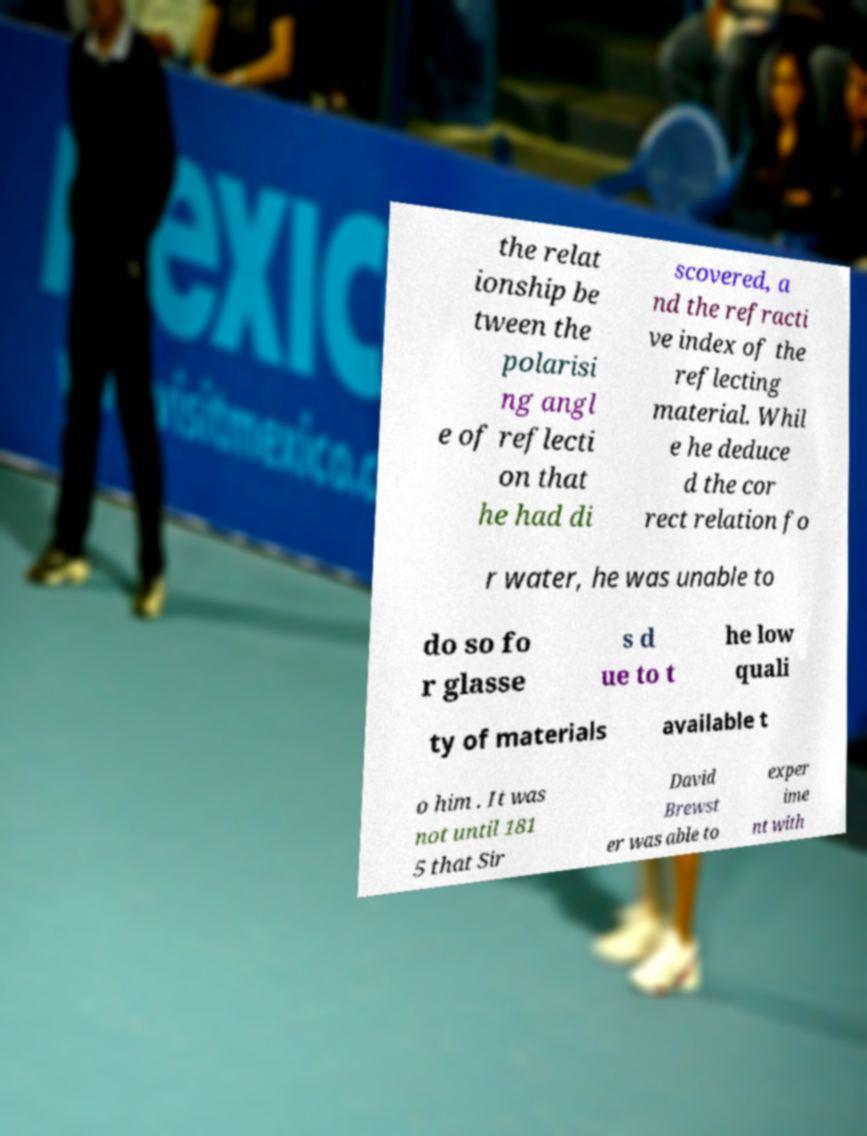Please read and relay the text visible in this image. What does it say? the relat ionship be tween the polarisi ng angl e of reflecti on that he had di scovered, a nd the refracti ve index of the reflecting material. Whil e he deduce d the cor rect relation fo r water, he was unable to do so fo r glasse s d ue to t he low quali ty of materials available t o him . It was not until 181 5 that Sir David Brewst er was able to exper ime nt with 